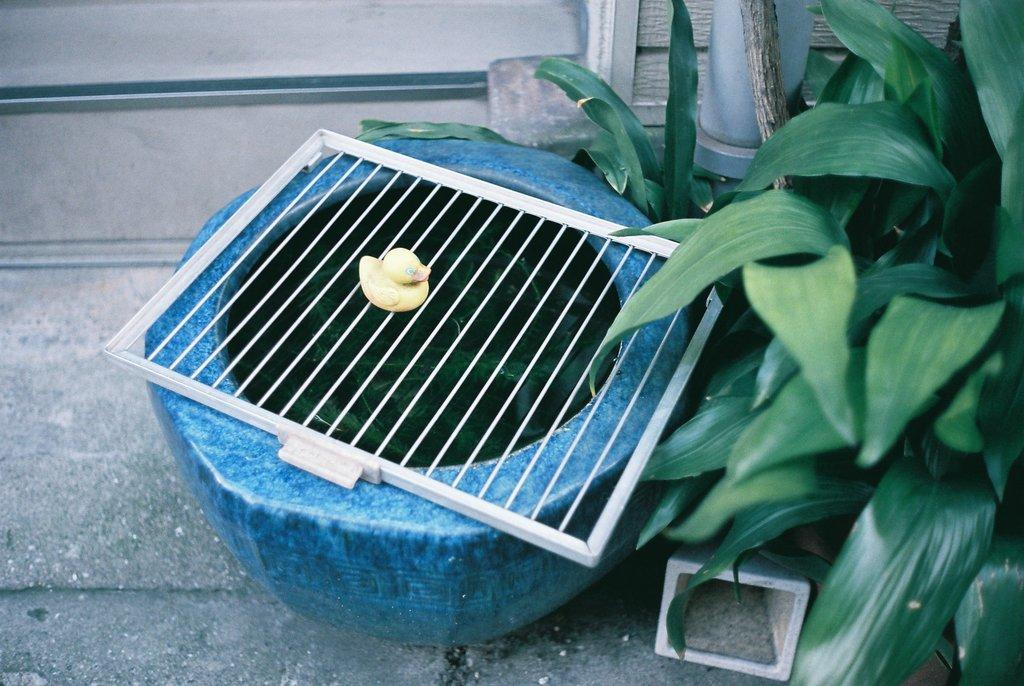What is on the pot in the image? There is a grill on a pot in the image. What type of toy is present in the image? There is a yellow toy duck in the image. What color are the plants in the image? The plants in the image are green. What color is the background wall in the image? The background wall is white. Is there a person wearing a shirt in the image? There is no person present in the image, so it cannot be determined if someone is wearing a shirt. Can you tell me the temperature of the grill in the image? The temperature of the grill cannot be determined from the image alone. 